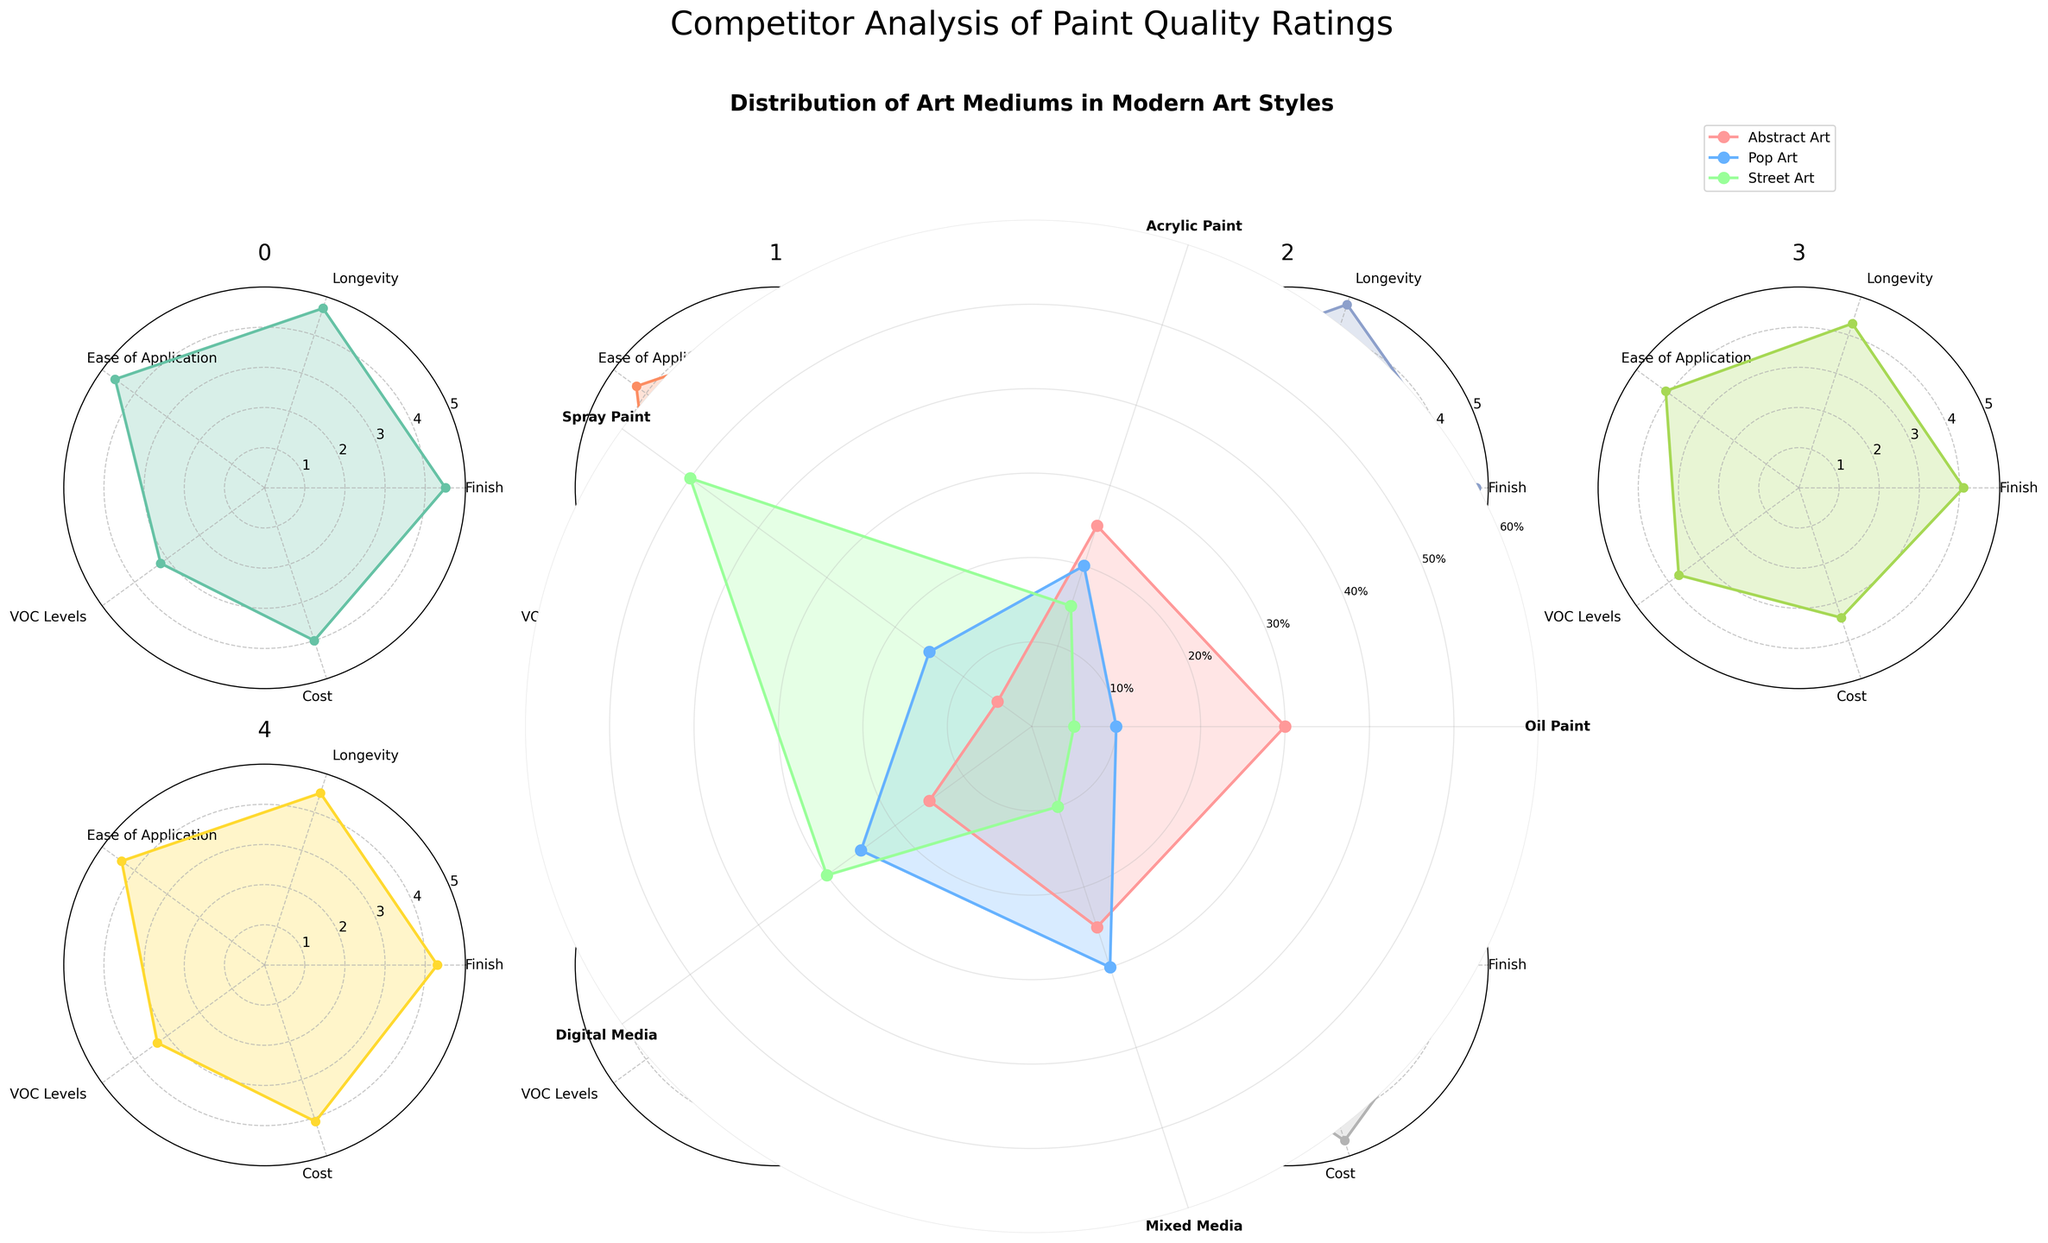What's the highest percentage of a medium used in Abstract Art? The title indicates the chart shows the distribution of art mediums in modern art styles, including Abstract Art. The outermost value on the Abstract Art line corresponds to "Mixed Media," at 25% according to the figure.
Answer: 30% Which medium is most prevalent in Street Art? Look at the line corresponding to Street Art. The medium with the highest outermost value on this line is "Spray Paint," indicating 50%.
Answer: Spray Paint Which art style uses Oil Paint the least? Check the values corresponding to Oil Paint for each of the art styles. The lowest value is 5%, which is for Street Art.
Answer: Street Art For Acrylic Paint, what's the total percentage in all art styles combined? Sum the percentages for Acrylic Paint across Abstract Art (25%), Pop Art (20%), and Street Art (15%). Calculation: 25% + 20% + 15% = 60%.
Answer: 60% Compare the usage of Digital Media in Pop Art and Street Art. Which one uses it more? Refer to the values on the chart for Digital Media in Pop Art (25%) and Street Art (30%). Street Art has a higher percentage.
Answer: Street Art How does Mixed Media usage in Pop Art compare to its usage in Abstract Art? The chart shows Mixed Media in Pop Art at 30% and in Abstract Art at 25%. Therefore, Pop Art has a higher value than Abstract Art.
Answer: Pop Art What's the average usage of Spray Paint across all art styles? Calculate the average by summing the percentages for Spray Paint: Abstract Art (5%), Pop Art (15%), Street Art (50%), and then divide by 3. Calculation: (5% + 15% + 50%) / 3 = 23.33%.
Answer: 23.33% Which art style has the smallest percentage for Digital Media? Look at the chart values: Digital Media in Abstract Art (15%), Pop Art (25%), and Street Art (30%). The smallest is for Abstract Art.
Answer: Abstract Art What’s the difference between the usage of Oil Paint in Abstract Art and its usage in Pop Art? Subtract the usage of Oil Paint in Pop Art (10%) from its usage in Abstract Art (30%). Calculation: 30% - 10% = 20%.
Answer: 20% Which medium appears to be most versatile across different art styles? Determine the medium by evaluating the consistent high percentages across all art styles. Mixed Media appears with higher values in Abstract Art (25%), Pop Art (30%), and Street Art (10%).
Answer: Mixed Media 